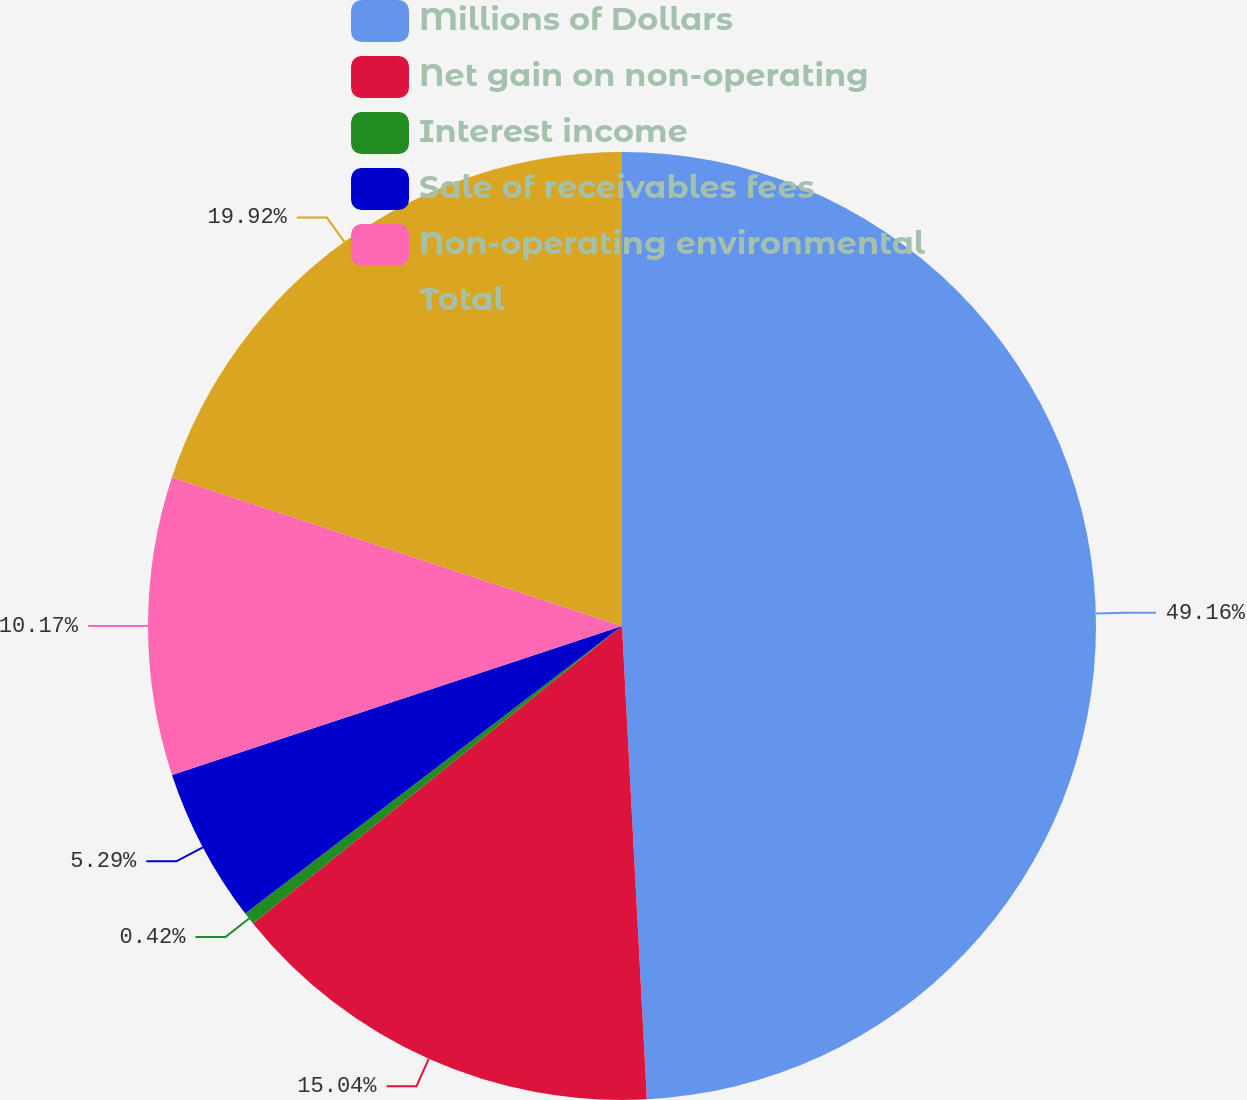<chart> <loc_0><loc_0><loc_500><loc_500><pie_chart><fcel>Millions of Dollars<fcel>Net gain on non-operating<fcel>Interest income<fcel>Sale of receivables fees<fcel>Non-operating environmental<fcel>Total<nl><fcel>49.17%<fcel>15.04%<fcel>0.42%<fcel>5.29%<fcel>10.17%<fcel>19.92%<nl></chart> 